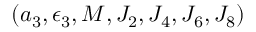Convert formula to latex. <formula><loc_0><loc_0><loc_500><loc_500>( a _ { 3 } , \epsilon _ { 3 } , M , J _ { 2 } , J _ { 4 } , J _ { 6 } , J _ { 8 } )</formula> 